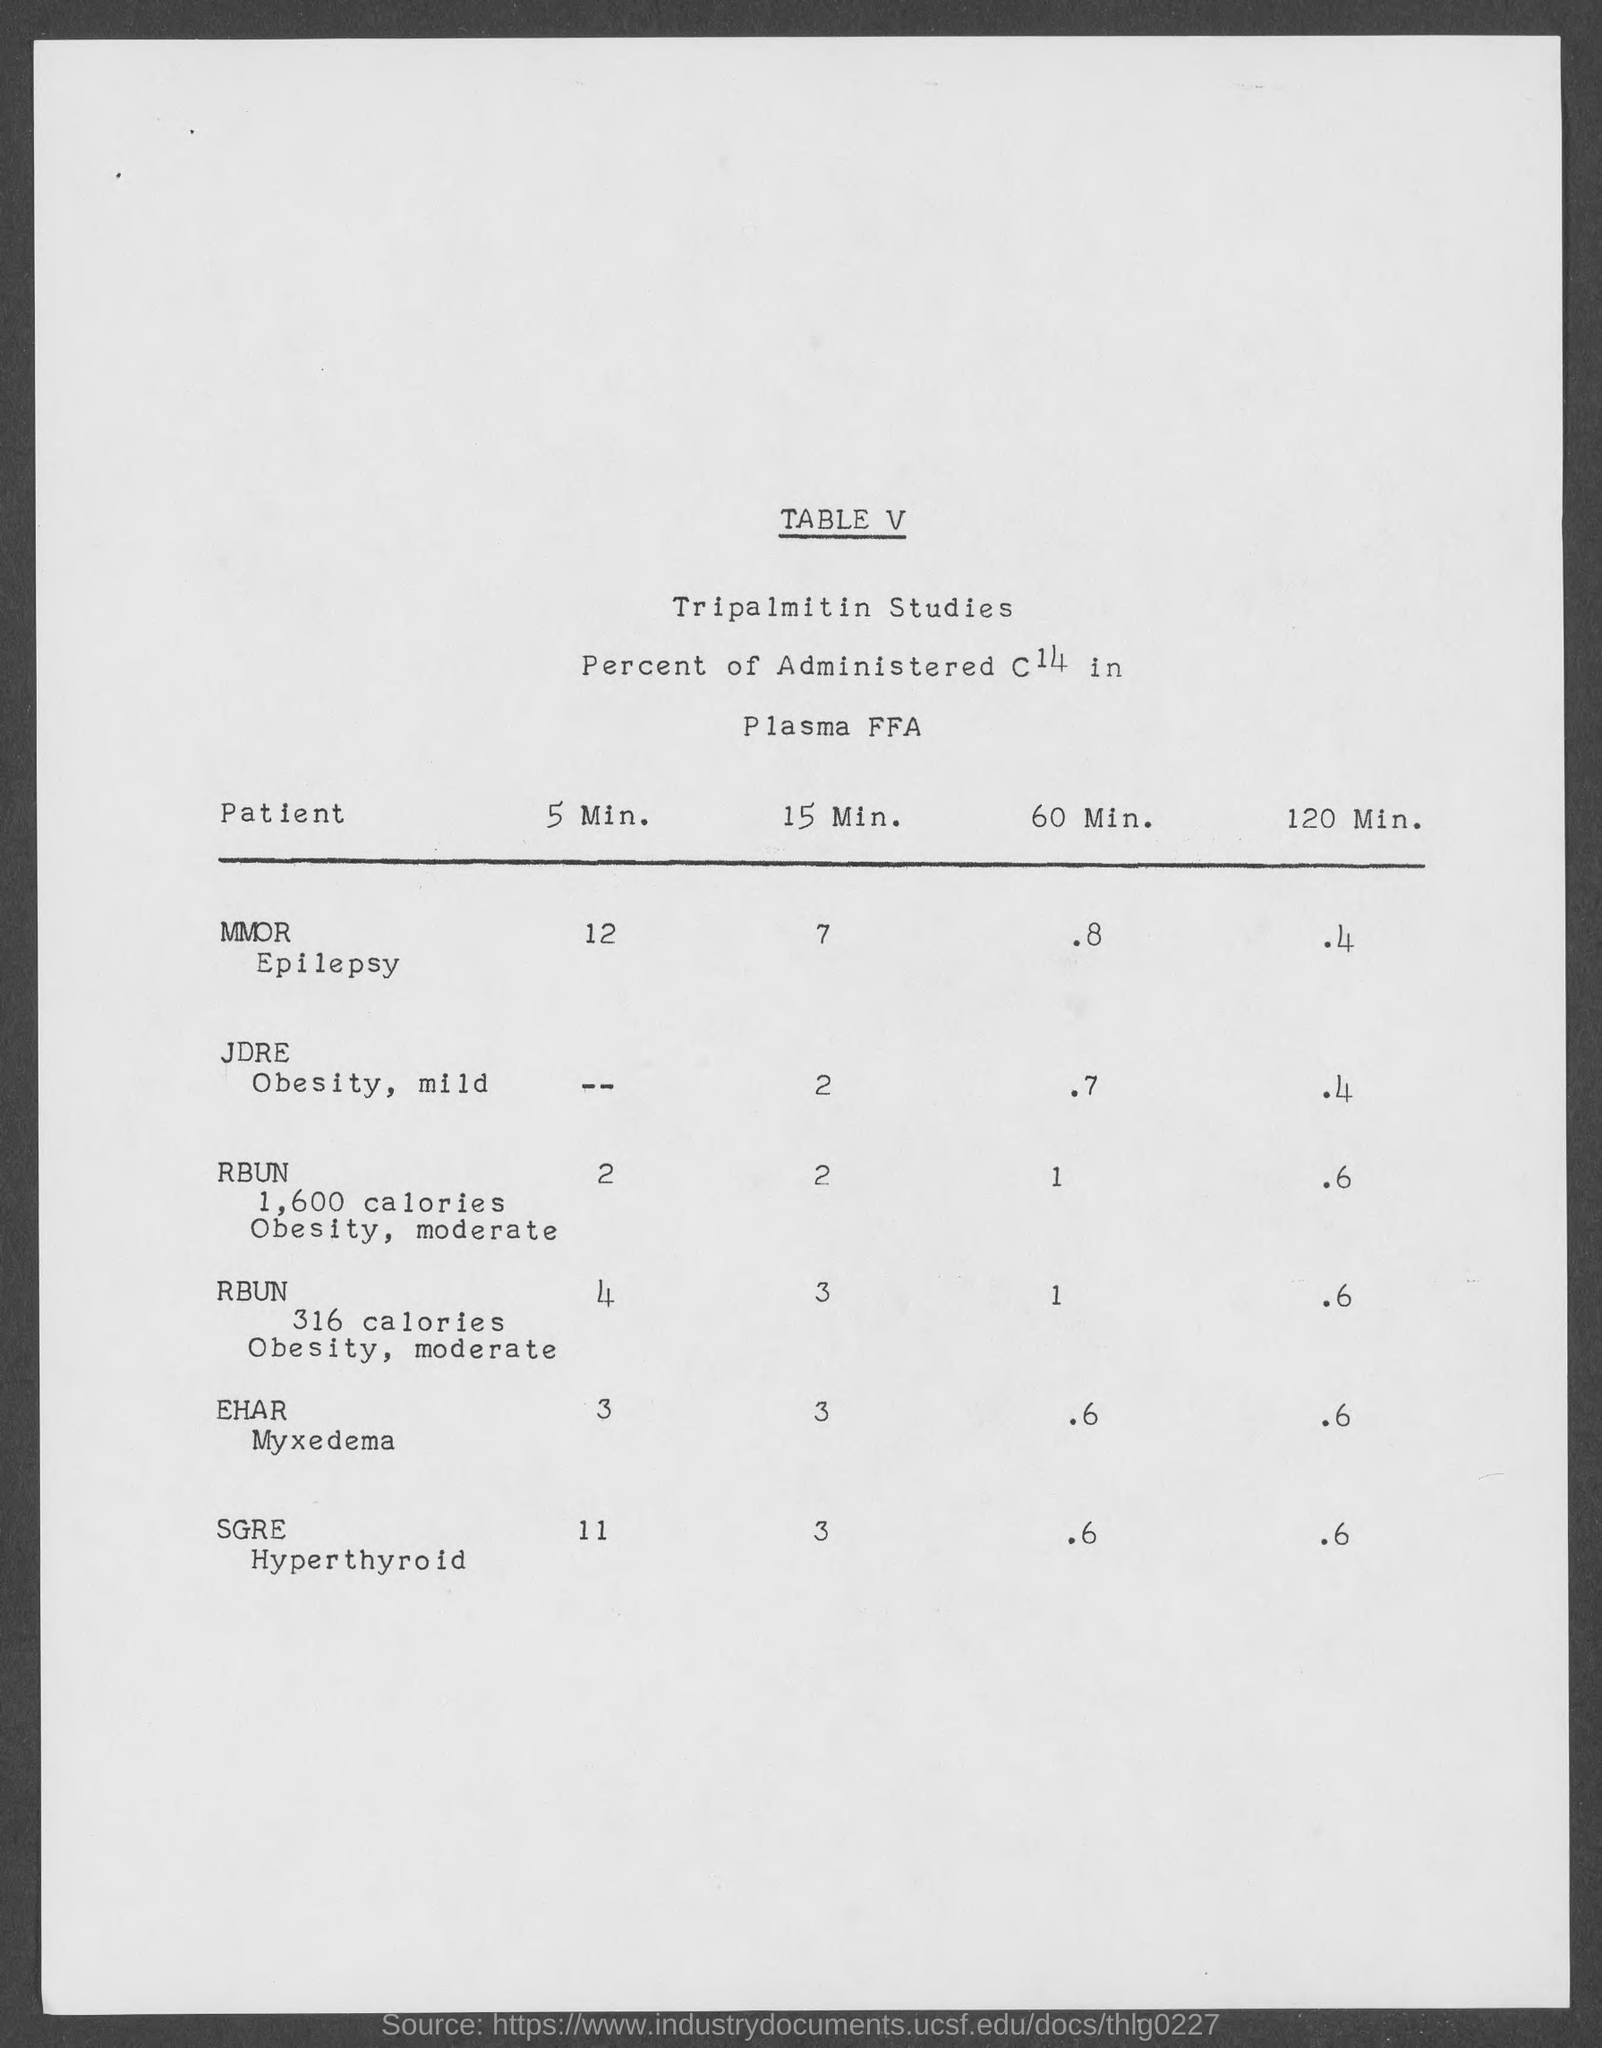Highlight a few significant elements in this photo. What is the table number?" is a question that requires an answer in order to provide the appropriate information. 